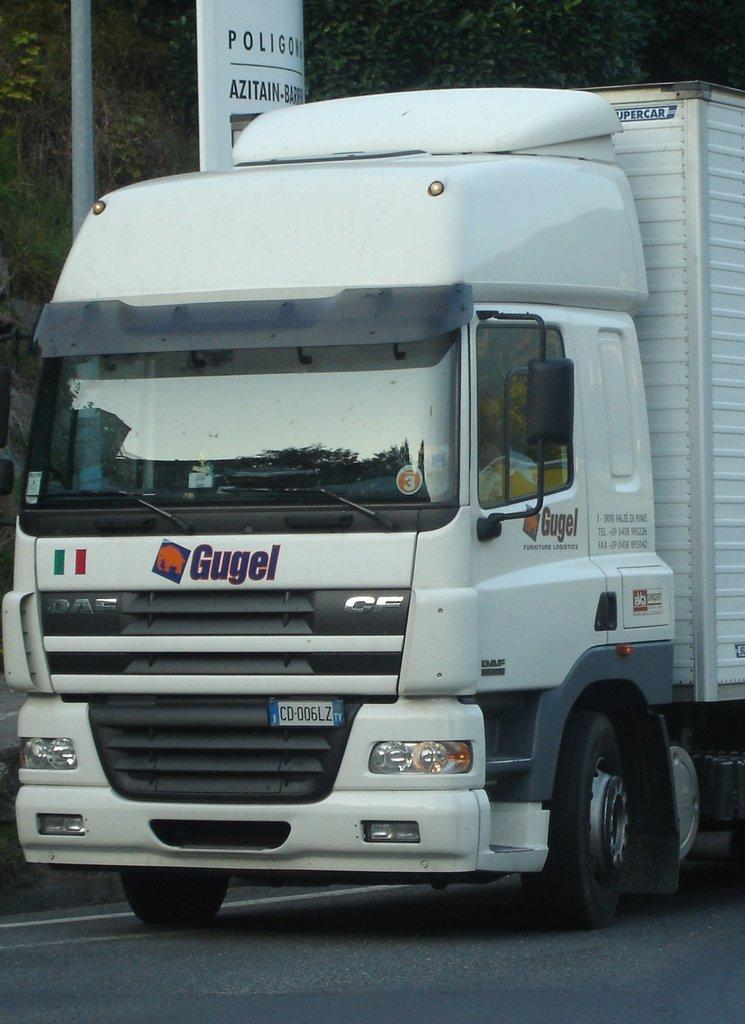What is on the road in the image? There is a vehicle on the road in the image. What can be seen on the vehicle? There is text written on the vehicle. What type of natural environment is visible in the image? There are trees visible in the image. What other text-related object is present in the image? There is a text board in the image. What structure can be seen in the image? There is a pole in the image. What type of umbrella is being used to cover the store in the image? There is no store or umbrella present in the image. What is the texture of the store's exterior in the image? There is no store present in the image, so it is not possible to determine its texture. 